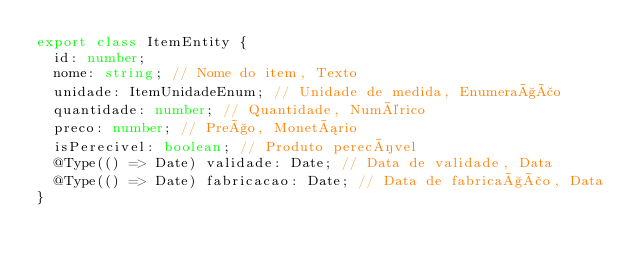<code> <loc_0><loc_0><loc_500><loc_500><_TypeScript_>export class ItemEntity {
  id: number;
  nome: string; // Nome do item, Texto
  unidade: ItemUnidadeEnum; // Unidade de medida, Enumeração
  quantidade: number; // Quantidade, Numérico
  preco: number; // Preço, Monetário
  isPerecivel: boolean; // Produto perecível
  @Type(() => Date) validade: Date; // Data de validade, Data
  @Type(() => Date) fabricacao: Date; // Data de fabricação, Data
}
</code> 